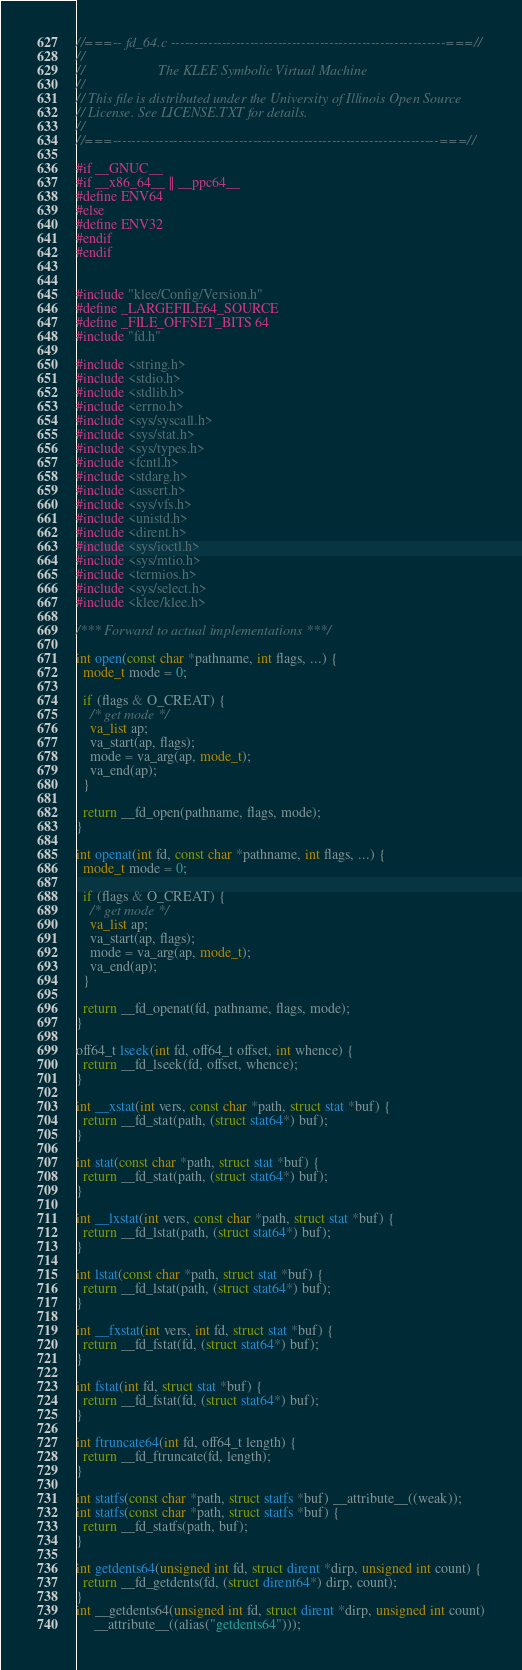<code> <loc_0><loc_0><loc_500><loc_500><_C_>//===-- fd_64.c -----------------------------------------------------------===//
//
//                     The KLEE Symbolic Virtual Machine
//
// This file is distributed under the University of Illinois Open Source
// License. See LICENSE.TXT for details.
//
//===----------------------------------------------------------------------===//

#if __GNUC__
#if __x86_64__ || __ppc64__
#define ENV64
#else
#define ENV32
#endif
#endif


#include "klee/Config/Version.h"
#define _LARGEFILE64_SOURCE
#define _FILE_OFFSET_BITS 64
#include "fd.h"

#include <string.h>
#include <stdio.h>
#include <stdlib.h>
#include <errno.h>
#include <sys/syscall.h>
#include <sys/stat.h>
#include <sys/types.h>
#include <fcntl.h>
#include <stdarg.h>
#include <assert.h>
#include <sys/vfs.h>
#include <unistd.h>
#include <dirent.h>
#include <sys/ioctl.h>
#include <sys/mtio.h>
#include <termios.h>
#include <sys/select.h>
#include <klee/klee.h>

/*** Forward to actual implementations ***/

int open(const char *pathname, int flags, ...) {
  mode_t mode = 0;
  
  if (flags & O_CREAT) {
    /* get mode */
    va_list ap;
    va_start(ap, flags);
    mode = va_arg(ap, mode_t);
    va_end(ap);
  }

  return __fd_open(pathname, flags, mode);
}

int openat(int fd, const char *pathname, int flags, ...) {
  mode_t mode = 0;
  
  if (flags & O_CREAT) {
    /* get mode */
    va_list ap;
    va_start(ap, flags);
    mode = va_arg(ap, mode_t);
    va_end(ap);
  }

  return __fd_openat(fd, pathname, flags, mode);
}

off64_t lseek(int fd, off64_t offset, int whence) {
  return __fd_lseek(fd, offset, whence);
}

int __xstat(int vers, const char *path, struct stat *buf) {
  return __fd_stat(path, (struct stat64*) buf);
}

int stat(const char *path, struct stat *buf) {
  return __fd_stat(path, (struct stat64*) buf);
}

int __lxstat(int vers, const char *path, struct stat *buf) {
  return __fd_lstat(path, (struct stat64*) buf);
}

int lstat(const char *path, struct stat *buf) {
  return __fd_lstat(path, (struct stat64*) buf);
}

int __fxstat(int vers, int fd, struct stat *buf) {
  return __fd_fstat(fd, (struct stat64*) buf);
}

int fstat(int fd, struct stat *buf) {
  return __fd_fstat(fd, (struct stat64*) buf);
}

int ftruncate64(int fd, off64_t length) {
  return __fd_ftruncate(fd, length);
}

int statfs(const char *path, struct statfs *buf) __attribute__((weak));
int statfs(const char *path, struct statfs *buf) {
  return __fd_statfs(path, buf);
}

int getdents64(unsigned int fd, struct dirent *dirp, unsigned int count) {
  return __fd_getdents(fd, (struct dirent64*) dirp, count);
}
int __getdents64(unsigned int fd, struct dirent *dirp, unsigned int count)
     __attribute__((alias("getdents64")));
</code> 